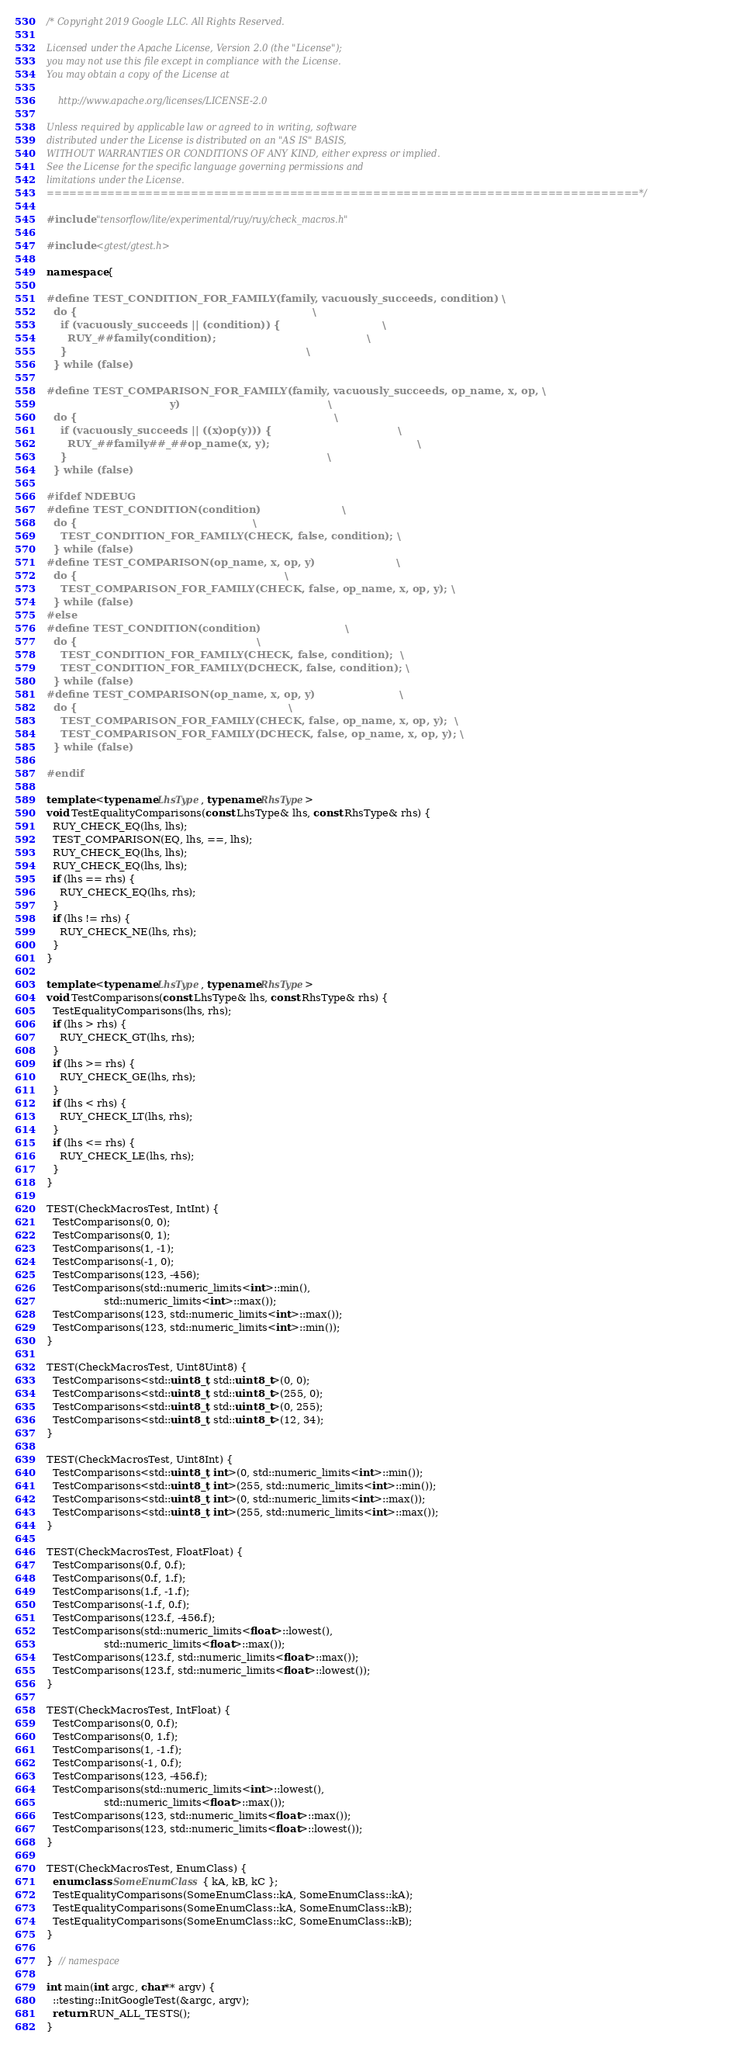Convert code to text. <code><loc_0><loc_0><loc_500><loc_500><_C++_>/* Copyright 2019 Google LLC. All Rights Reserved.

Licensed under the Apache License, Version 2.0 (the "License");
you may not use this file except in compliance with the License.
You may obtain a copy of the License at

    http://www.apache.org/licenses/LICENSE-2.0

Unless required by applicable law or agreed to in writing, software
distributed under the License is distributed on an "AS IS" BASIS,
WITHOUT WARRANTIES OR CONDITIONS OF ANY KIND, either express or implied.
See the License for the specific language governing permissions and
limitations under the License.
==============================================================================*/

#include "tensorflow/lite/experimental/ruy/ruy/check_macros.h"

#include <gtest/gtest.h>

namespace {

#define TEST_CONDITION_FOR_FAMILY(family, vacuously_succeeds, condition) \
  do {                                                                   \
    if (vacuously_succeeds || (condition)) {                             \
      RUY_##family(condition);                                           \
    }                                                                    \
  } while (false)

#define TEST_COMPARISON_FOR_FAMILY(family, vacuously_succeeds, op_name, x, op, \
                                   y)                                          \
  do {                                                                         \
    if (vacuously_succeeds || ((x)op(y))) {                                    \
      RUY_##family##_##op_name(x, y);                                          \
    }                                                                          \
  } while (false)

#ifdef NDEBUG
#define TEST_CONDITION(condition)                       \
  do {                                                  \
    TEST_CONDITION_FOR_FAMILY(CHECK, false, condition); \
  } while (false)
#define TEST_COMPARISON(op_name, x, op, y)                       \
  do {                                                           \
    TEST_COMPARISON_FOR_FAMILY(CHECK, false, op_name, x, op, y); \
  } while (false)
#else
#define TEST_CONDITION(condition)                        \
  do {                                                   \
    TEST_CONDITION_FOR_FAMILY(CHECK, false, condition);  \
    TEST_CONDITION_FOR_FAMILY(DCHECK, false, condition); \
  } while (false)
#define TEST_COMPARISON(op_name, x, op, y)                        \
  do {                                                            \
    TEST_COMPARISON_FOR_FAMILY(CHECK, false, op_name, x, op, y);  \
    TEST_COMPARISON_FOR_FAMILY(DCHECK, false, op_name, x, op, y); \
  } while (false)

#endif

template <typename LhsType, typename RhsType>
void TestEqualityComparisons(const LhsType& lhs, const RhsType& rhs) {
  RUY_CHECK_EQ(lhs, lhs);
  TEST_COMPARISON(EQ, lhs, ==, lhs);
  RUY_CHECK_EQ(lhs, lhs);
  RUY_CHECK_EQ(lhs, lhs);
  if (lhs == rhs) {
    RUY_CHECK_EQ(lhs, rhs);
  }
  if (lhs != rhs) {
    RUY_CHECK_NE(lhs, rhs);
  }
}

template <typename LhsType, typename RhsType>
void TestComparisons(const LhsType& lhs, const RhsType& rhs) {
  TestEqualityComparisons(lhs, rhs);
  if (lhs > rhs) {
    RUY_CHECK_GT(lhs, rhs);
  }
  if (lhs >= rhs) {
    RUY_CHECK_GE(lhs, rhs);
  }
  if (lhs < rhs) {
    RUY_CHECK_LT(lhs, rhs);
  }
  if (lhs <= rhs) {
    RUY_CHECK_LE(lhs, rhs);
  }
}

TEST(CheckMacrosTest, IntInt) {
  TestComparisons(0, 0);
  TestComparisons(0, 1);
  TestComparisons(1, -1);
  TestComparisons(-1, 0);
  TestComparisons(123, -456);
  TestComparisons(std::numeric_limits<int>::min(),
                  std::numeric_limits<int>::max());
  TestComparisons(123, std::numeric_limits<int>::max());
  TestComparisons(123, std::numeric_limits<int>::min());
}

TEST(CheckMacrosTest, Uint8Uint8) {
  TestComparisons<std::uint8_t, std::uint8_t>(0, 0);
  TestComparisons<std::uint8_t, std::uint8_t>(255, 0);
  TestComparisons<std::uint8_t, std::uint8_t>(0, 255);
  TestComparisons<std::uint8_t, std::uint8_t>(12, 34);
}

TEST(CheckMacrosTest, Uint8Int) {
  TestComparisons<std::uint8_t, int>(0, std::numeric_limits<int>::min());
  TestComparisons<std::uint8_t, int>(255, std::numeric_limits<int>::min());
  TestComparisons<std::uint8_t, int>(0, std::numeric_limits<int>::max());
  TestComparisons<std::uint8_t, int>(255, std::numeric_limits<int>::max());
}

TEST(CheckMacrosTest, FloatFloat) {
  TestComparisons(0.f, 0.f);
  TestComparisons(0.f, 1.f);
  TestComparisons(1.f, -1.f);
  TestComparisons(-1.f, 0.f);
  TestComparisons(123.f, -456.f);
  TestComparisons(std::numeric_limits<float>::lowest(),
                  std::numeric_limits<float>::max());
  TestComparisons(123.f, std::numeric_limits<float>::max());
  TestComparisons(123.f, std::numeric_limits<float>::lowest());
}

TEST(CheckMacrosTest, IntFloat) {
  TestComparisons(0, 0.f);
  TestComparisons(0, 1.f);
  TestComparisons(1, -1.f);
  TestComparisons(-1, 0.f);
  TestComparisons(123, -456.f);
  TestComparisons(std::numeric_limits<int>::lowest(),
                  std::numeric_limits<float>::max());
  TestComparisons(123, std::numeric_limits<float>::max());
  TestComparisons(123, std::numeric_limits<float>::lowest());
}

TEST(CheckMacrosTest, EnumClass) {
  enum class SomeEnumClass { kA, kB, kC };
  TestEqualityComparisons(SomeEnumClass::kA, SomeEnumClass::kA);
  TestEqualityComparisons(SomeEnumClass::kA, SomeEnumClass::kB);
  TestEqualityComparisons(SomeEnumClass::kC, SomeEnumClass::kB);
}

}  // namespace

int main(int argc, char** argv) {
  ::testing::InitGoogleTest(&argc, argv);
  return RUN_ALL_TESTS();
}
</code> 